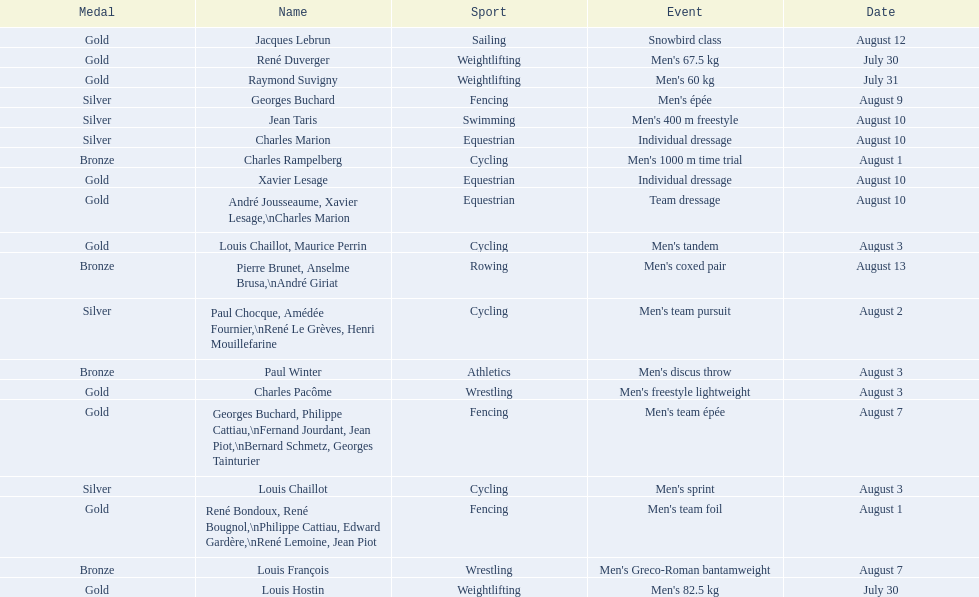What is next date that is listed after august 7th? August 1. 